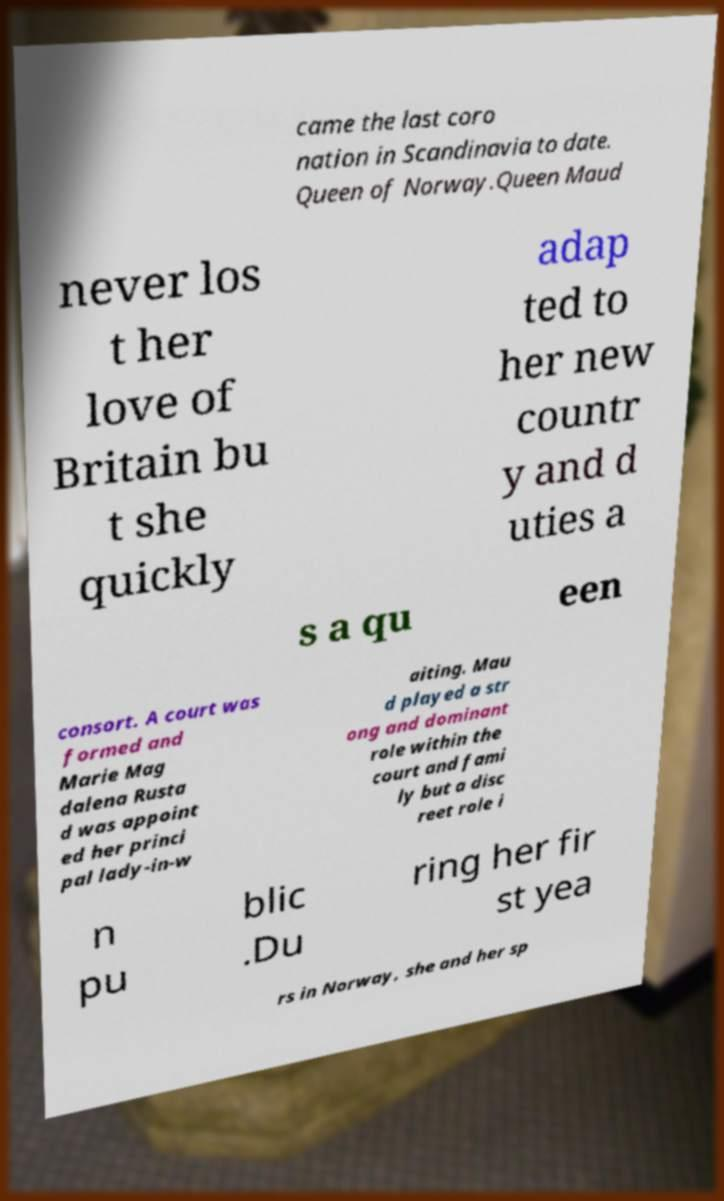For documentation purposes, I need the text within this image transcribed. Could you provide that? came the last coro nation in Scandinavia to date. Queen of Norway.Queen Maud never los t her love of Britain bu t she quickly adap ted to her new countr y and d uties a s a qu een consort. A court was formed and Marie Mag dalena Rusta d was appoint ed her princi pal lady-in-w aiting. Mau d played a str ong and dominant role within the court and fami ly but a disc reet role i n pu blic .Du ring her fir st yea rs in Norway, she and her sp 